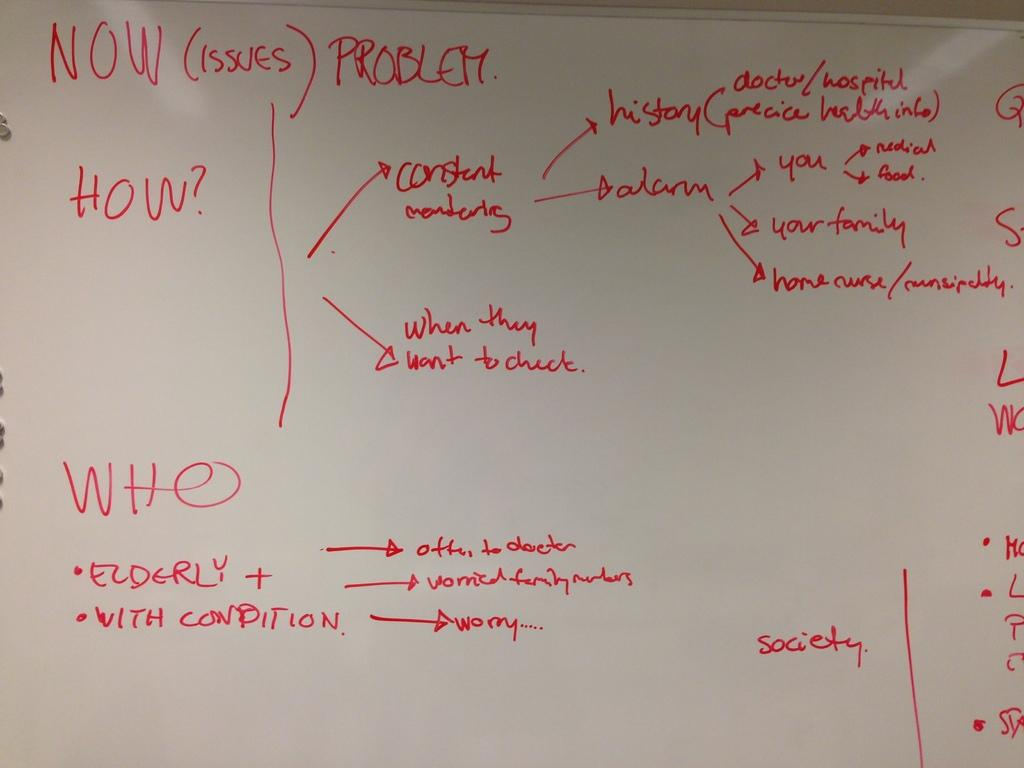<image>
Offer a succinct explanation of the picture presented. White board which has the word "WHO" near the bottom left. 